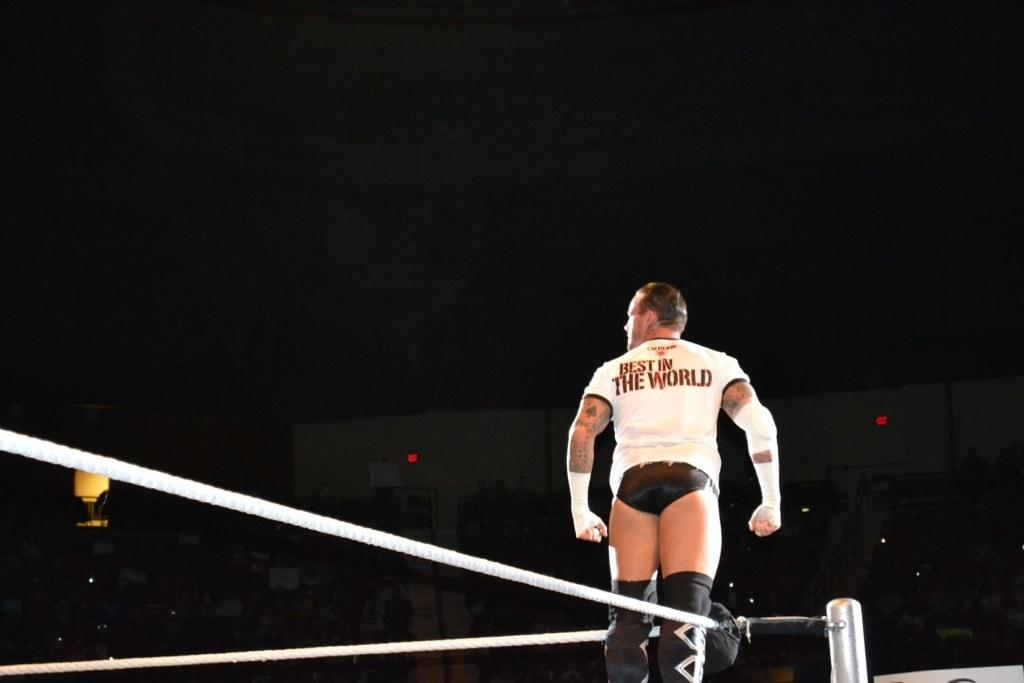<image>
Relay a brief, clear account of the picture shown. The wrestler standing on the rings claims to be the best in the world. 